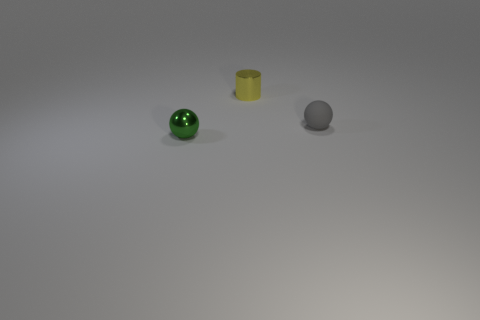Looking at the lighting in the scene, where would you say the light source is located? The light appears to be coming from the upper side of the image, given the direction of the shadows cast by the objects which extend down and to the right. 